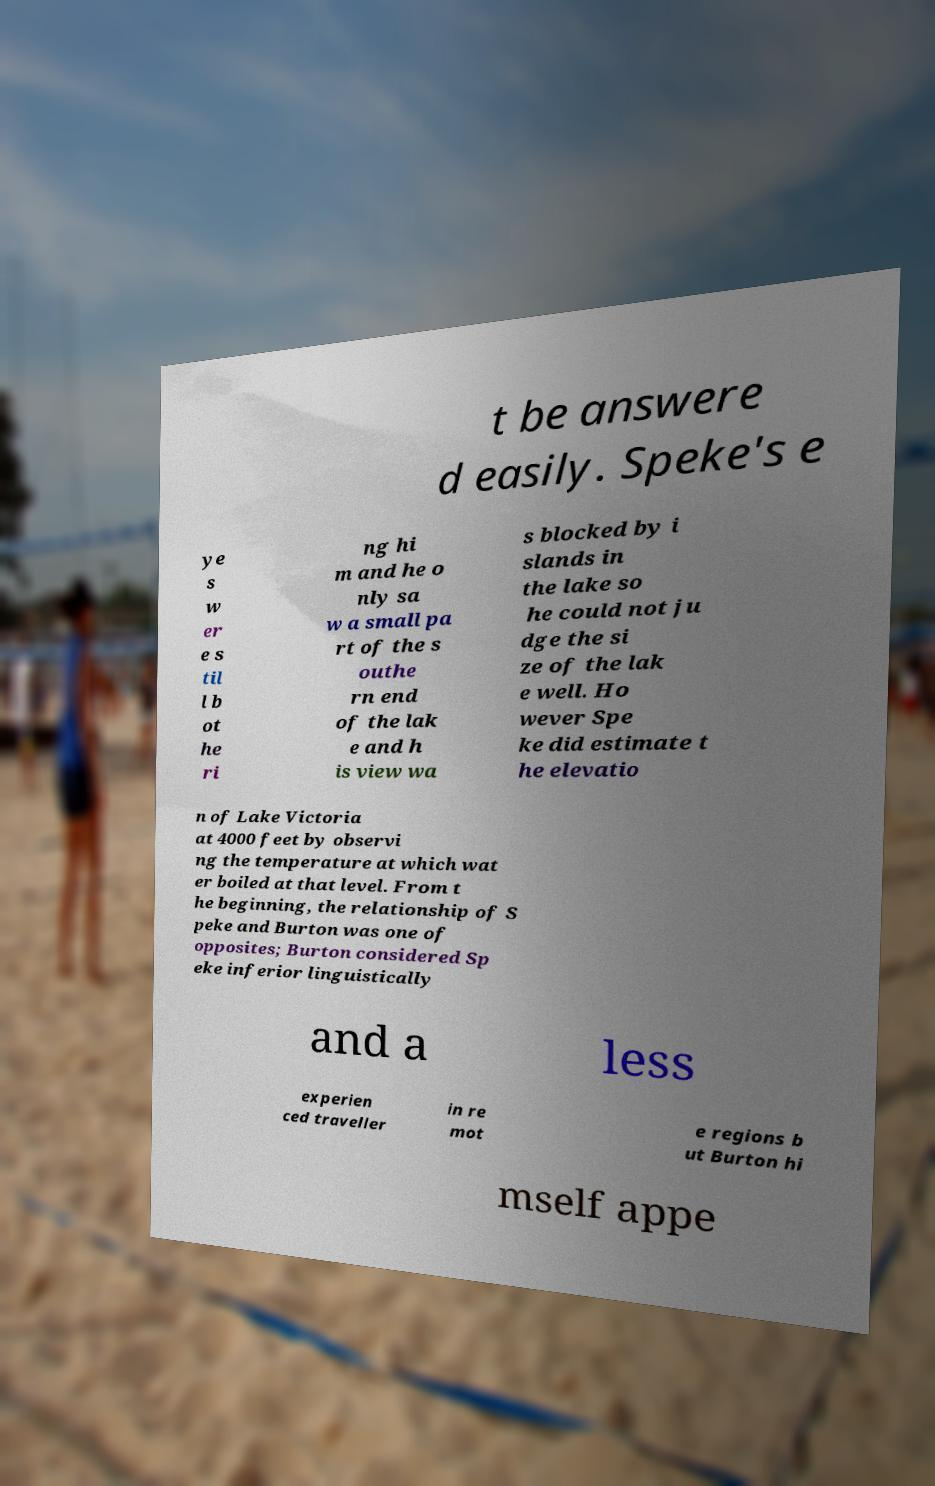Can you read and provide the text displayed in the image?This photo seems to have some interesting text. Can you extract and type it out for me? t be answere d easily. Speke's e ye s w er e s til l b ot he ri ng hi m and he o nly sa w a small pa rt of the s outhe rn end of the lak e and h is view wa s blocked by i slands in the lake so he could not ju dge the si ze of the lak e well. Ho wever Spe ke did estimate t he elevatio n of Lake Victoria at 4000 feet by observi ng the temperature at which wat er boiled at that level. From t he beginning, the relationship of S peke and Burton was one of opposites; Burton considered Sp eke inferior linguistically and a less experien ced traveller in re mot e regions b ut Burton hi mself appe 